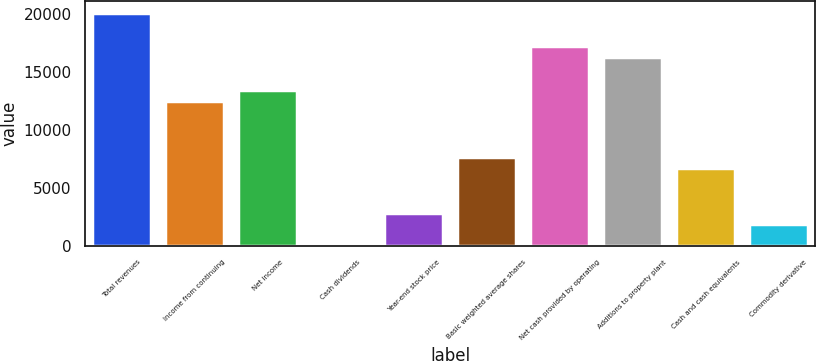Convert chart. <chart><loc_0><loc_0><loc_500><loc_500><bar_chart><fcel>Total revenues<fcel>Income from continuing<fcel>Net income<fcel>Cash dividends<fcel>Year-end stock price<fcel>Basic weighted average shares<fcel>Net cash provided by operating<fcel>Additions to property plant<fcel>Cash and cash equivalents<fcel>Commodity derivative<nl><fcel>20136.5<fcel>12465.6<fcel>13424.5<fcel>0.28<fcel>2876.89<fcel>7671.24<fcel>17259.9<fcel>16301.1<fcel>6712.37<fcel>1918.02<nl></chart> 